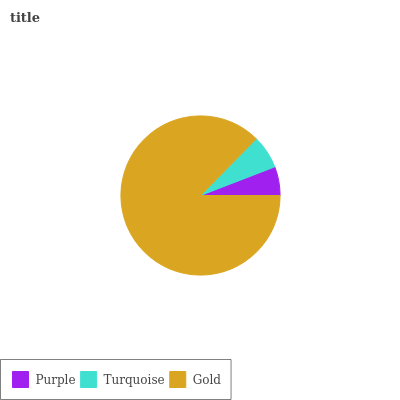Is Purple the minimum?
Answer yes or no. Yes. Is Gold the maximum?
Answer yes or no. Yes. Is Turquoise the minimum?
Answer yes or no. No. Is Turquoise the maximum?
Answer yes or no. No. Is Turquoise greater than Purple?
Answer yes or no. Yes. Is Purple less than Turquoise?
Answer yes or no. Yes. Is Purple greater than Turquoise?
Answer yes or no. No. Is Turquoise less than Purple?
Answer yes or no. No. Is Turquoise the high median?
Answer yes or no. Yes. Is Turquoise the low median?
Answer yes or no. Yes. Is Gold the high median?
Answer yes or no. No. Is Gold the low median?
Answer yes or no. No. 